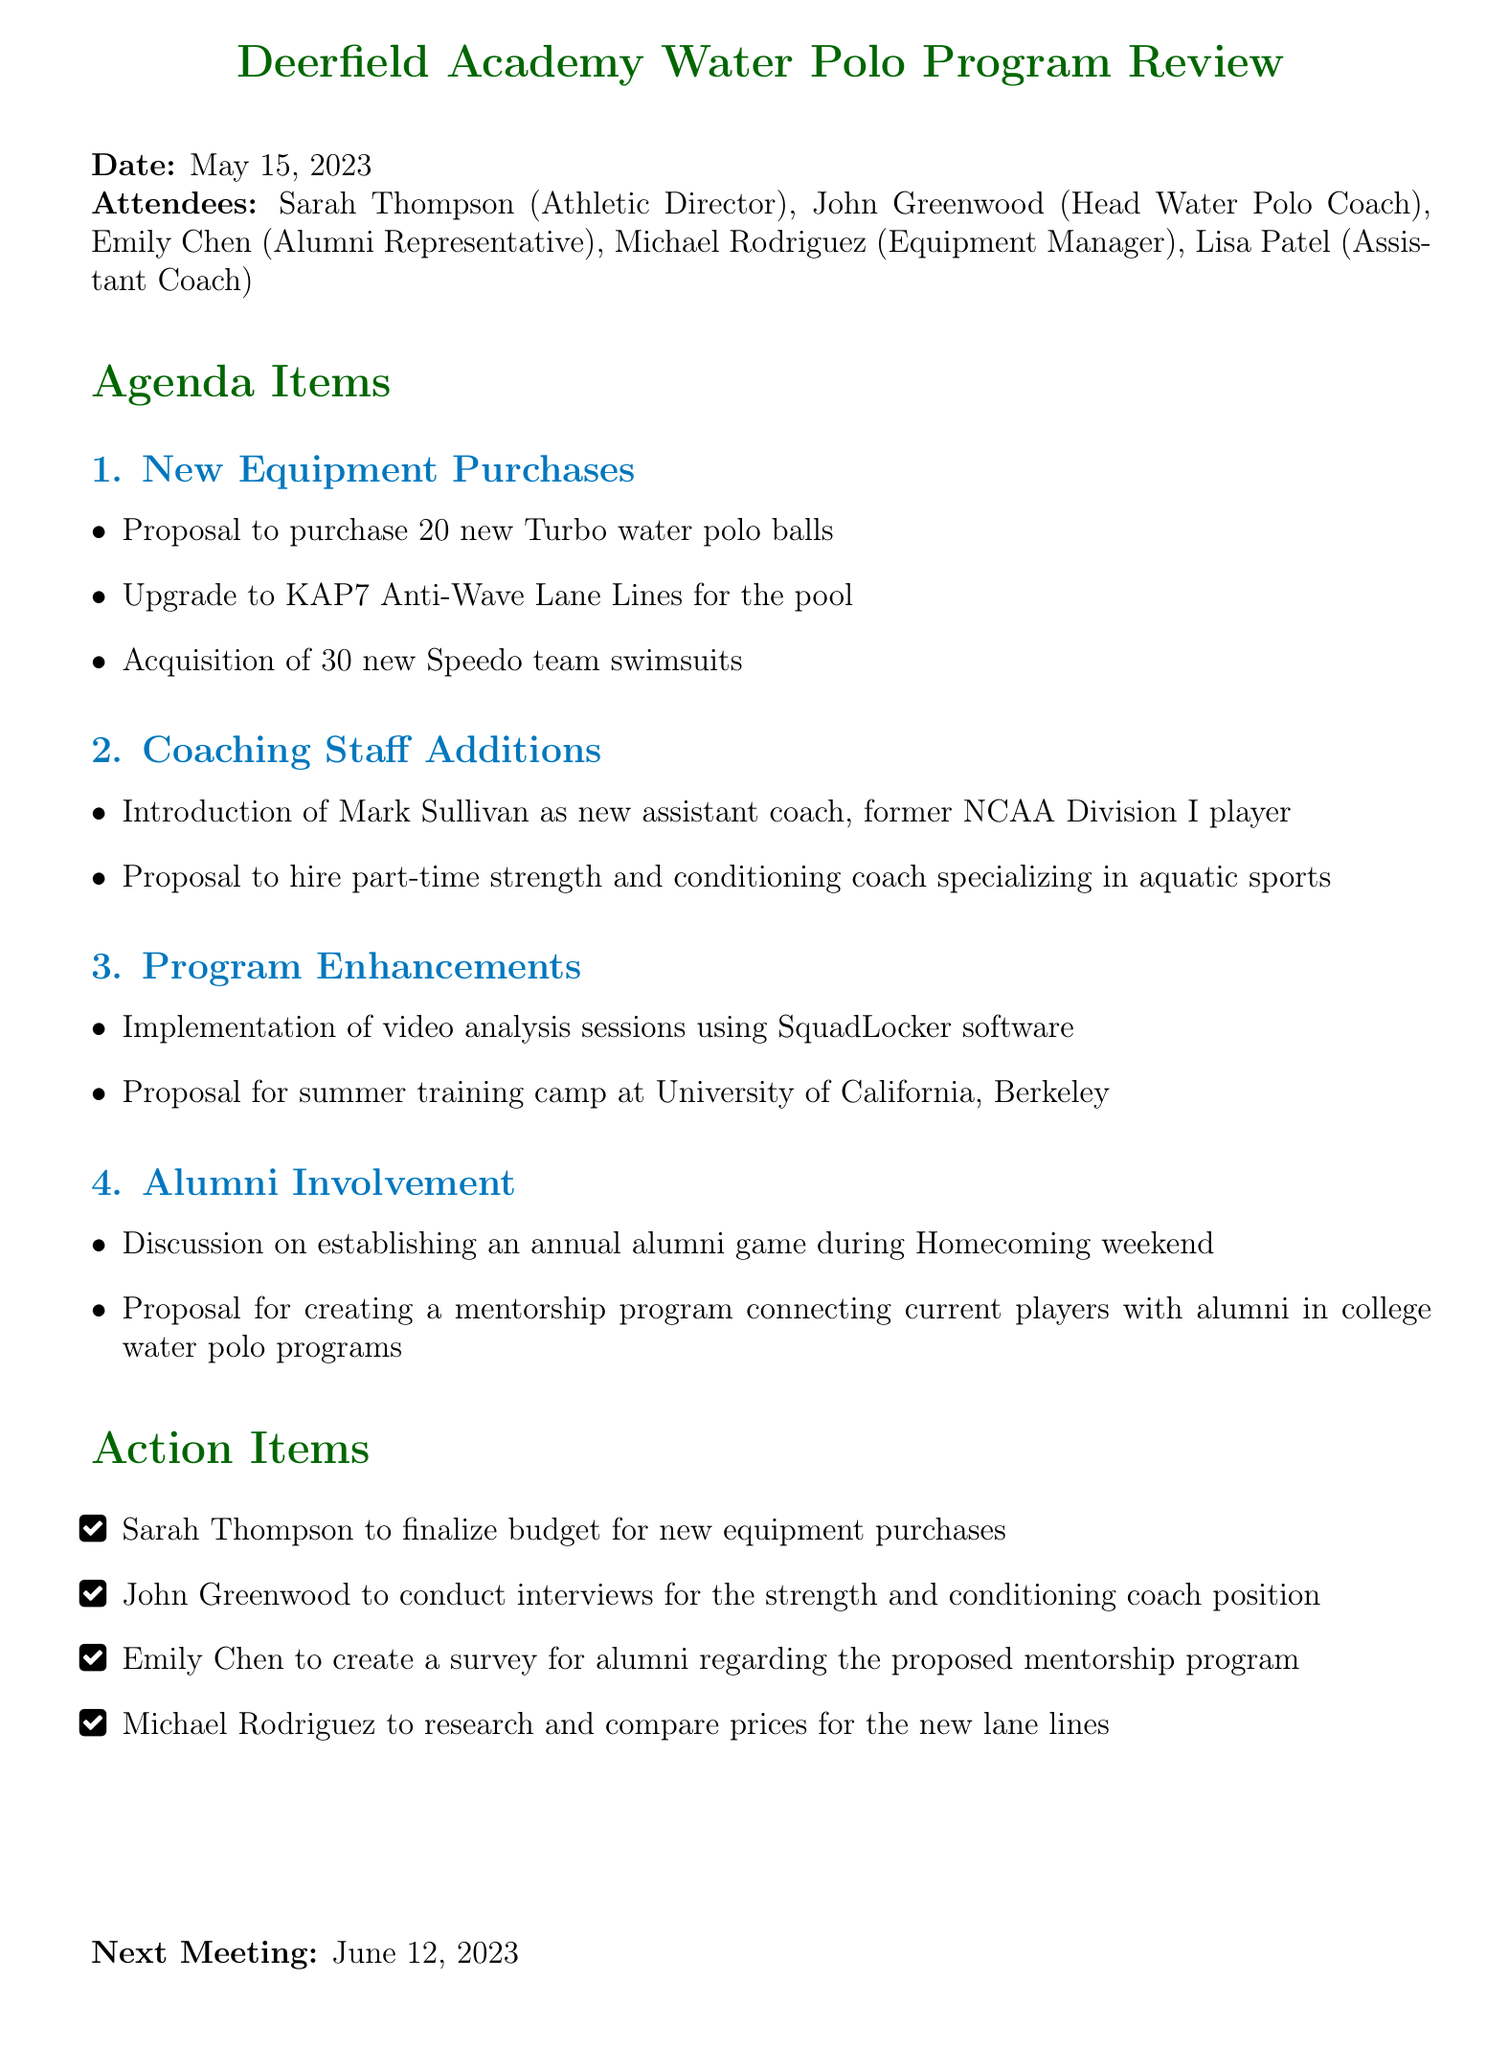What is the meeting title? The meeting title is stated at the top of the document.
Answer: Deerfield Academy Water Polo Program Review Who is the Athletic Director? The Athletic Director is listed among the attendees.
Answer: Sarah Thompson How many new water polo balls are proposed for purchase? The proposal for new equipment includes a specific quantity of water polo balls.
Answer: 20 Who will be the new assistant coach? The name of the new assistant coach is mentioned in the coaching staff additions.
Answer: Mark Sullivan What software is proposed for video analysis sessions? The document specifies a software tool for video analysis in the program enhancements section.
Answer: SquadLocker When is the next meeting scheduled? The date for the next meeting is mentioned at the end of the document.
Answer: June 12, 2023 What is one of the action items for Sarah Thompson? The action items section includes specific tasks assigned to attendees.
Answer: Finalize budget for new equipment purchases What proposal is made regarding alumni involvement? The alumni involvement section details a specific proposal related to alumni connections.
Answer: Create a mentorship program connecting current players with alumni in college water polo programs How many swimsuits are proposed for acquisition? The details regarding new equipment purchases include a specific quantity of swimsuits.
Answer: 30 